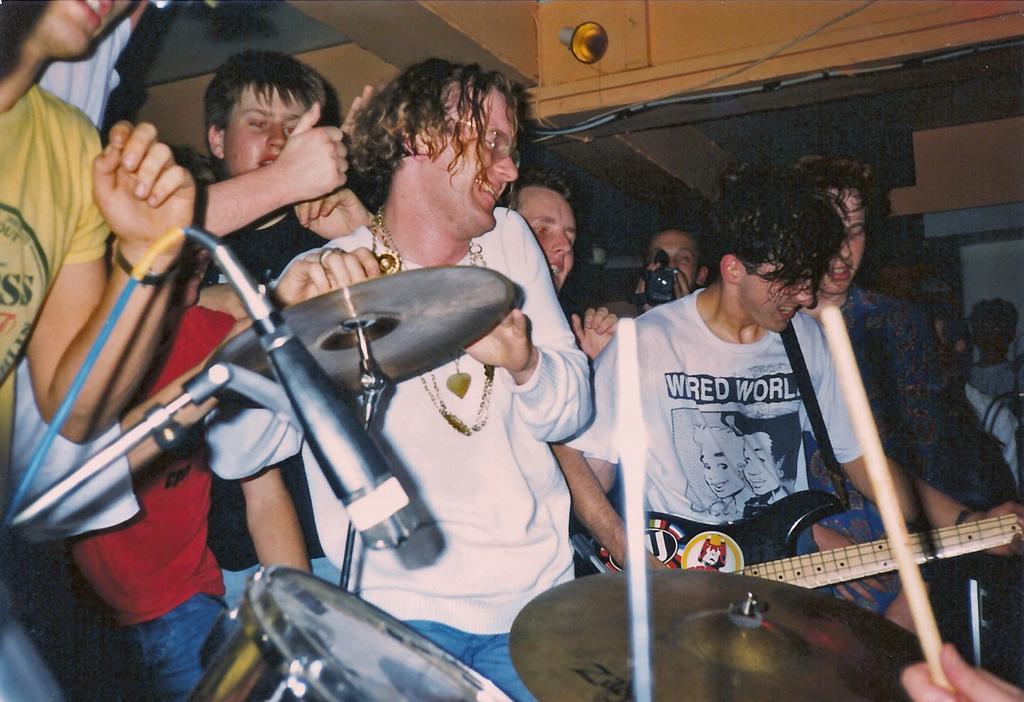Could you give a brief overview of what you see in this image? In this picture we can see a group of people man in center smiling and dancing beside to him one person is taking picture and one is playing guitar and in front of them we can see drums, mic. 